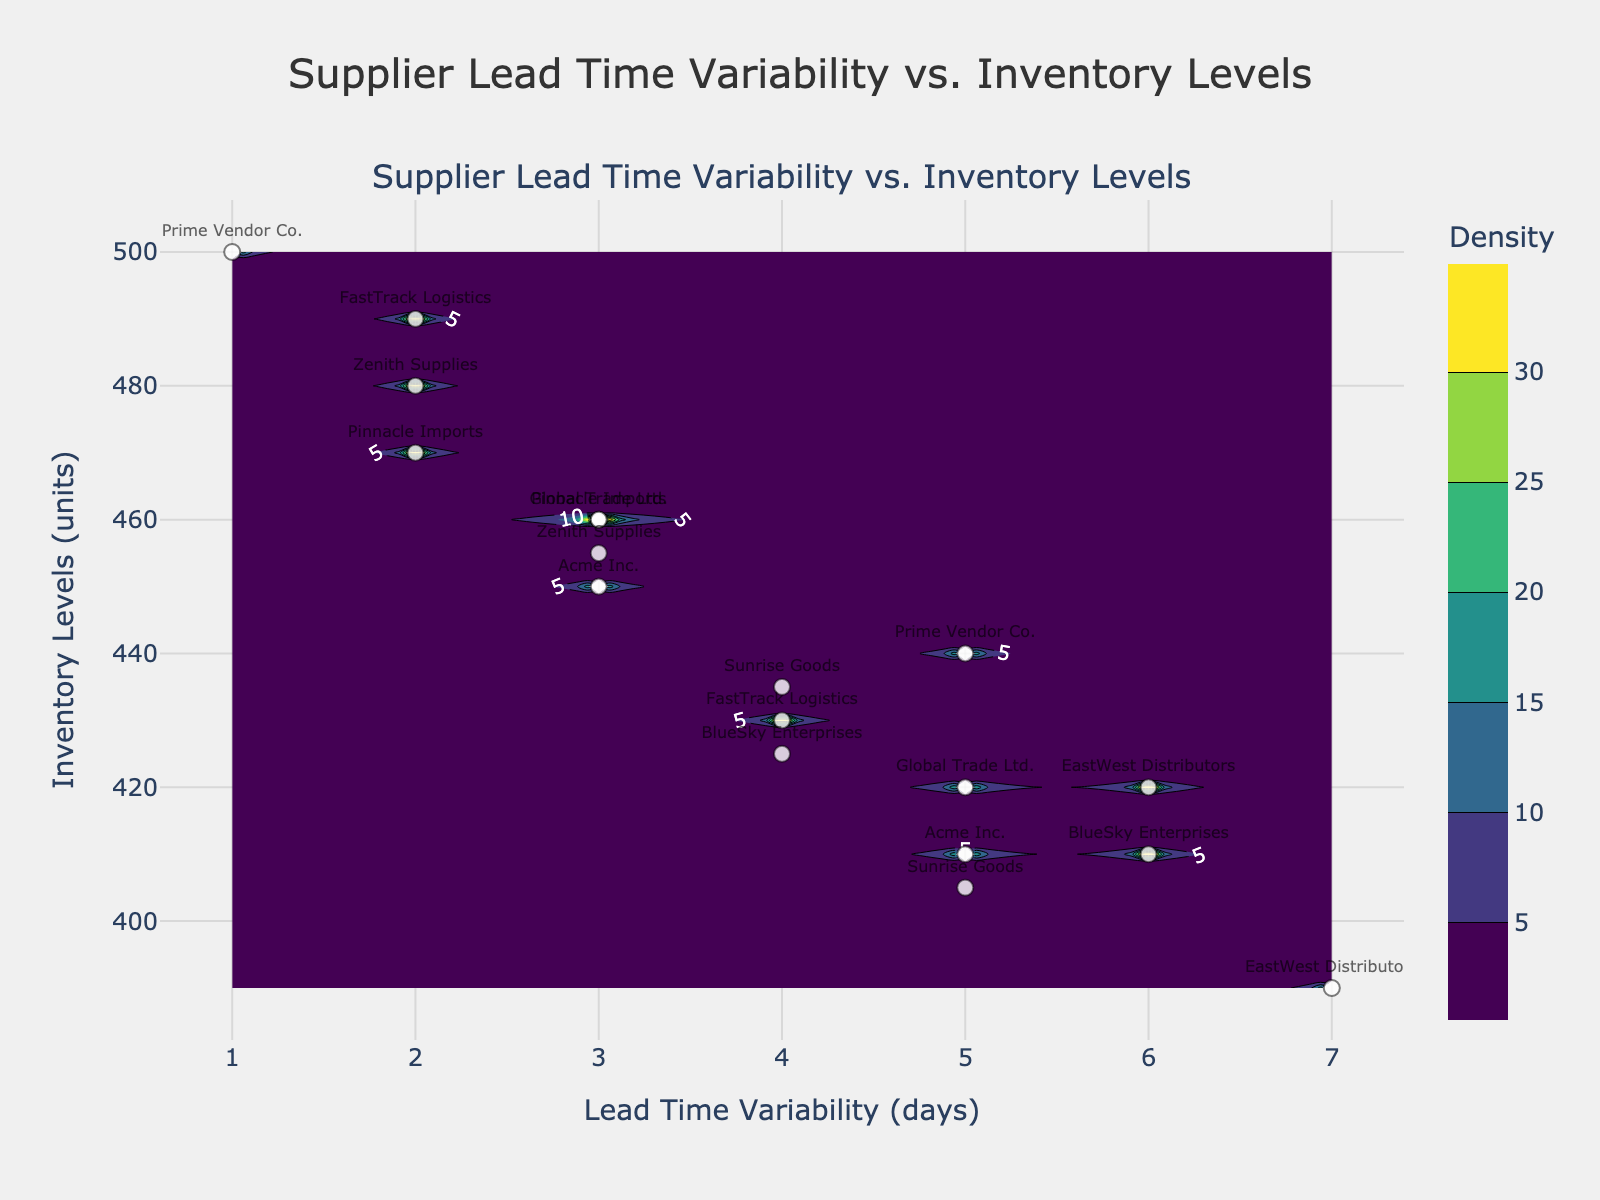What is the title of the figure? The title is clearly displayed at the top center of the figure. It reads "Supplier Lead Time Variability vs. Inventory Levels".
Answer: Supplier Lead Time Variability vs. Inventory Levels How many suppliers are represented in the scatter plot? Each point in the scatter plot represents a supplier, and each point is labeled with the supplier's name. By counting the distinct labels, we can determine the number of suppliers.
Answer: 9 Which supplier has the highest lead time variability? By looking at the x-axis values for the scatter plot points, the supplier with the highest lead time variability can be identified. "EastWest Distributors" is at 7 days, which is the highest value.
Answer: EastWest Distributors What is the inventory level for "Prime Vendor Co." when its lead time variability is 1 day? Locate "Prime Vendor Co." on the scatter plot with a lead time variability of 1 day. The corresponding y-value (inventory level) of this point is 500 units.
Answer: 500 units Which supplier appears multiple times with different inventory levels and lead time variability? By observing the scatter plot, "Global Trade Ltd." appears twice with different combinations of inventory levels and lead time variability.
Answer: Global Trade Ltd What is the inventory level range represented in the figure? Locate the minimum and maximum values on the y-axis. The lowest value is 390 units, and the highest is 500 units.
Answer: 390 - 500 units Which supplier has the lowest lead time variability but not the highest inventory level? From the scatter plot, "Prime Vendor Co." has the lowest lead time variability (1 day) but has an inventory level of 500 units, which is not the highest among the listed values.
Answer: Prime Vendor Co What is the approximate inventory level when the lead time variability is 4 days for most suppliers? By observing where most scatter points with a lead time variability of 4 days fall on the y-axis, around 430-435 units is the most common value.
Answer: approximately 430-435 units Which supplier has the inventory levels that are closest together? By identifying the points for each supplier, "Zenith Supplies" has inventory levels of 480 and 455 units, which are closest compared to other suppliers.
Answer: Zenith Supplies How do the colors in the contour plot indicate density? The contour colors range from the bottom of the colorscale. Denser areas (higher density) are typically indicated by the brighter or more intense colors, usually found towards the center.
Answer: Bright/intense colors show higher density 